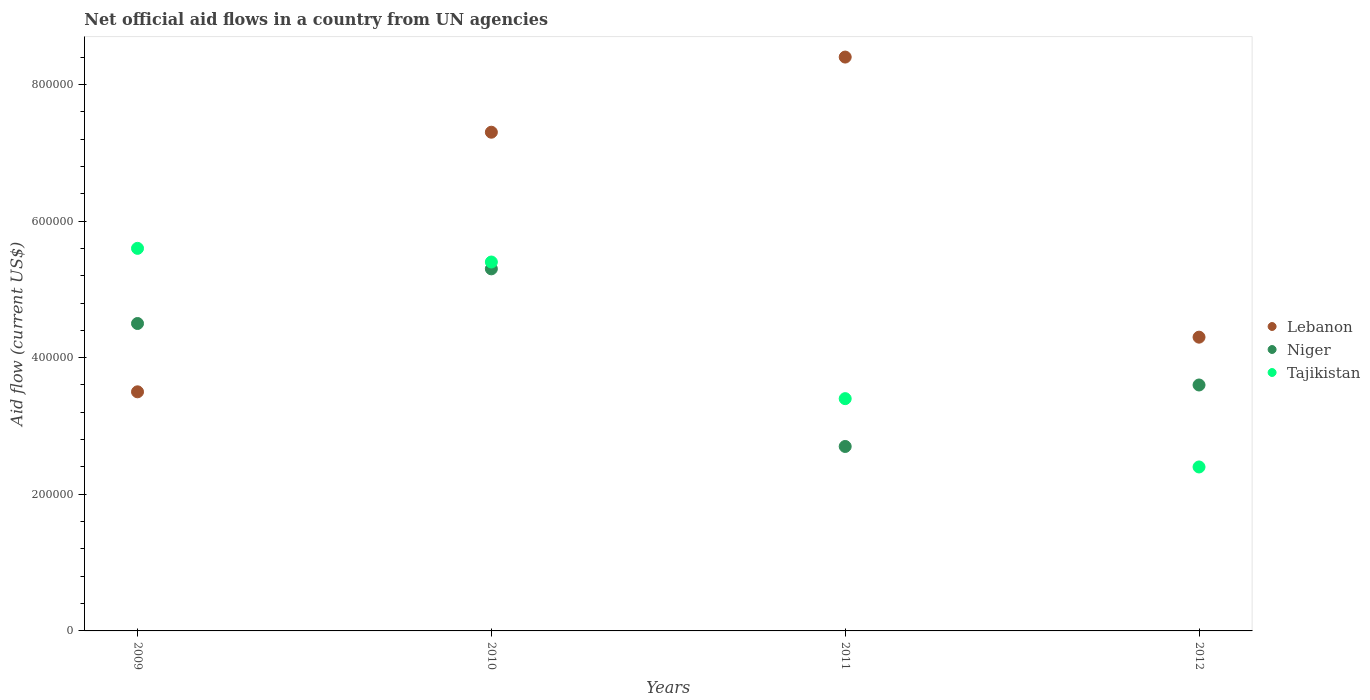How many different coloured dotlines are there?
Offer a terse response. 3. What is the net official aid flow in Niger in 2010?
Your answer should be compact. 5.30e+05. Across all years, what is the maximum net official aid flow in Lebanon?
Ensure brevity in your answer.  8.40e+05. Across all years, what is the minimum net official aid flow in Tajikistan?
Your answer should be very brief. 2.40e+05. In which year was the net official aid flow in Niger minimum?
Offer a terse response. 2011. What is the total net official aid flow in Lebanon in the graph?
Your response must be concise. 2.35e+06. What is the difference between the net official aid flow in Tajikistan in 2010 and that in 2011?
Your response must be concise. 2.00e+05. What is the difference between the net official aid flow in Niger in 2011 and the net official aid flow in Tajikistan in 2010?
Your response must be concise. -2.70e+05. What is the average net official aid flow in Lebanon per year?
Your answer should be compact. 5.88e+05. In the year 2009, what is the difference between the net official aid flow in Tajikistan and net official aid flow in Niger?
Offer a terse response. 1.10e+05. What is the ratio of the net official aid flow in Niger in 2010 to that in 2012?
Your answer should be very brief. 1.47. Is the net official aid flow in Tajikistan in 2010 less than that in 2011?
Keep it short and to the point. No. What is the difference between the highest and the lowest net official aid flow in Lebanon?
Provide a succinct answer. 4.90e+05. In how many years, is the net official aid flow in Lebanon greater than the average net official aid flow in Lebanon taken over all years?
Ensure brevity in your answer.  2. Is the sum of the net official aid flow in Tajikistan in 2009 and 2010 greater than the maximum net official aid flow in Lebanon across all years?
Provide a succinct answer. Yes. Is it the case that in every year, the sum of the net official aid flow in Lebanon and net official aid flow in Tajikistan  is greater than the net official aid flow in Niger?
Give a very brief answer. Yes. Is the net official aid flow in Tajikistan strictly greater than the net official aid flow in Lebanon over the years?
Give a very brief answer. No. Is the net official aid flow in Tajikistan strictly less than the net official aid flow in Lebanon over the years?
Keep it short and to the point. No. How many years are there in the graph?
Offer a terse response. 4. Are the values on the major ticks of Y-axis written in scientific E-notation?
Your answer should be compact. No. Does the graph contain any zero values?
Your response must be concise. No. Where does the legend appear in the graph?
Your response must be concise. Center right. How are the legend labels stacked?
Your answer should be very brief. Vertical. What is the title of the graph?
Provide a short and direct response. Net official aid flows in a country from UN agencies. What is the Aid flow (current US$) of Lebanon in 2009?
Keep it short and to the point. 3.50e+05. What is the Aid flow (current US$) in Tajikistan in 2009?
Make the answer very short. 5.60e+05. What is the Aid flow (current US$) in Lebanon in 2010?
Your answer should be very brief. 7.30e+05. What is the Aid flow (current US$) of Niger in 2010?
Give a very brief answer. 5.30e+05. What is the Aid flow (current US$) of Tajikistan in 2010?
Your answer should be compact. 5.40e+05. What is the Aid flow (current US$) in Lebanon in 2011?
Make the answer very short. 8.40e+05. What is the Aid flow (current US$) of Lebanon in 2012?
Your answer should be very brief. 4.30e+05. What is the Aid flow (current US$) in Tajikistan in 2012?
Your response must be concise. 2.40e+05. Across all years, what is the maximum Aid flow (current US$) of Lebanon?
Give a very brief answer. 8.40e+05. Across all years, what is the maximum Aid flow (current US$) in Niger?
Your answer should be very brief. 5.30e+05. Across all years, what is the maximum Aid flow (current US$) in Tajikistan?
Make the answer very short. 5.60e+05. Across all years, what is the minimum Aid flow (current US$) in Lebanon?
Make the answer very short. 3.50e+05. Across all years, what is the minimum Aid flow (current US$) of Niger?
Provide a succinct answer. 2.70e+05. What is the total Aid flow (current US$) of Lebanon in the graph?
Your answer should be very brief. 2.35e+06. What is the total Aid flow (current US$) in Niger in the graph?
Provide a succinct answer. 1.61e+06. What is the total Aid flow (current US$) in Tajikistan in the graph?
Your answer should be very brief. 1.68e+06. What is the difference between the Aid flow (current US$) in Lebanon in 2009 and that in 2010?
Your answer should be compact. -3.80e+05. What is the difference between the Aid flow (current US$) in Lebanon in 2009 and that in 2011?
Keep it short and to the point. -4.90e+05. What is the difference between the Aid flow (current US$) in Lebanon in 2009 and that in 2012?
Your answer should be compact. -8.00e+04. What is the difference between the Aid flow (current US$) in Niger in 2009 and that in 2012?
Provide a short and direct response. 9.00e+04. What is the difference between the Aid flow (current US$) in Tajikistan in 2009 and that in 2012?
Give a very brief answer. 3.20e+05. What is the difference between the Aid flow (current US$) of Lebanon in 2010 and that in 2011?
Your response must be concise. -1.10e+05. What is the difference between the Aid flow (current US$) in Niger in 2010 and that in 2011?
Offer a very short reply. 2.60e+05. What is the difference between the Aid flow (current US$) in Lebanon in 2010 and that in 2012?
Provide a succinct answer. 3.00e+05. What is the difference between the Aid flow (current US$) in Lebanon in 2009 and the Aid flow (current US$) in Niger in 2010?
Offer a terse response. -1.80e+05. What is the difference between the Aid flow (current US$) of Niger in 2009 and the Aid flow (current US$) of Tajikistan in 2010?
Ensure brevity in your answer.  -9.00e+04. What is the difference between the Aid flow (current US$) of Lebanon in 2009 and the Aid flow (current US$) of Tajikistan in 2011?
Your answer should be very brief. 10000. What is the difference between the Aid flow (current US$) in Lebanon in 2010 and the Aid flow (current US$) in Tajikistan in 2011?
Your answer should be very brief. 3.90e+05. What is the difference between the Aid flow (current US$) of Niger in 2010 and the Aid flow (current US$) of Tajikistan in 2011?
Your response must be concise. 1.90e+05. What is the difference between the Aid flow (current US$) in Lebanon in 2010 and the Aid flow (current US$) in Tajikistan in 2012?
Give a very brief answer. 4.90e+05. What is the difference between the Aid flow (current US$) of Lebanon in 2011 and the Aid flow (current US$) of Tajikistan in 2012?
Keep it short and to the point. 6.00e+05. What is the difference between the Aid flow (current US$) of Niger in 2011 and the Aid flow (current US$) of Tajikistan in 2012?
Provide a succinct answer. 3.00e+04. What is the average Aid flow (current US$) of Lebanon per year?
Provide a succinct answer. 5.88e+05. What is the average Aid flow (current US$) of Niger per year?
Your answer should be very brief. 4.02e+05. What is the average Aid flow (current US$) in Tajikistan per year?
Give a very brief answer. 4.20e+05. In the year 2009, what is the difference between the Aid flow (current US$) of Lebanon and Aid flow (current US$) of Niger?
Ensure brevity in your answer.  -1.00e+05. In the year 2009, what is the difference between the Aid flow (current US$) in Niger and Aid flow (current US$) in Tajikistan?
Offer a very short reply. -1.10e+05. In the year 2011, what is the difference between the Aid flow (current US$) in Lebanon and Aid flow (current US$) in Niger?
Your answer should be compact. 5.70e+05. In the year 2011, what is the difference between the Aid flow (current US$) of Lebanon and Aid flow (current US$) of Tajikistan?
Your response must be concise. 5.00e+05. In the year 2012, what is the difference between the Aid flow (current US$) in Lebanon and Aid flow (current US$) in Niger?
Your answer should be compact. 7.00e+04. What is the ratio of the Aid flow (current US$) of Lebanon in 2009 to that in 2010?
Your answer should be compact. 0.48. What is the ratio of the Aid flow (current US$) of Niger in 2009 to that in 2010?
Make the answer very short. 0.85. What is the ratio of the Aid flow (current US$) in Tajikistan in 2009 to that in 2010?
Provide a short and direct response. 1.04. What is the ratio of the Aid flow (current US$) in Lebanon in 2009 to that in 2011?
Make the answer very short. 0.42. What is the ratio of the Aid flow (current US$) of Tajikistan in 2009 to that in 2011?
Your response must be concise. 1.65. What is the ratio of the Aid flow (current US$) in Lebanon in 2009 to that in 2012?
Keep it short and to the point. 0.81. What is the ratio of the Aid flow (current US$) in Niger in 2009 to that in 2012?
Offer a terse response. 1.25. What is the ratio of the Aid flow (current US$) of Tajikistan in 2009 to that in 2012?
Your answer should be compact. 2.33. What is the ratio of the Aid flow (current US$) in Lebanon in 2010 to that in 2011?
Ensure brevity in your answer.  0.87. What is the ratio of the Aid flow (current US$) in Niger in 2010 to that in 2011?
Offer a terse response. 1.96. What is the ratio of the Aid flow (current US$) in Tajikistan in 2010 to that in 2011?
Give a very brief answer. 1.59. What is the ratio of the Aid flow (current US$) in Lebanon in 2010 to that in 2012?
Provide a short and direct response. 1.7. What is the ratio of the Aid flow (current US$) in Niger in 2010 to that in 2012?
Ensure brevity in your answer.  1.47. What is the ratio of the Aid flow (current US$) in Tajikistan in 2010 to that in 2012?
Make the answer very short. 2.25. What is the ratio of the Aid flow (current US$) in Lebanon in 2011 to that in 2012?
Offer a terse response. 1.95. What is the ratio of the Aid flow (current US$) in Tajikistan in 2011 to that in 2012?
Your answer should be very brief. 1.42. What is the difference between the highest and the second highest Aid flow (current US$) in Niger?
Offer a terse response. 8.00e+04. What is the difference between the highest and the lowest Aid flow (current US$) of Lebanon?
Provide a succinct answer. 4.90e+05. 